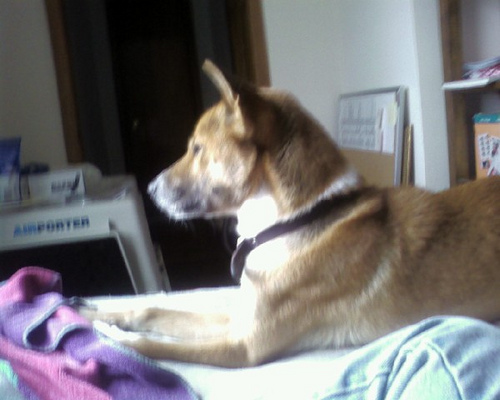Please transcribe the text in this image. AIRPORTER 